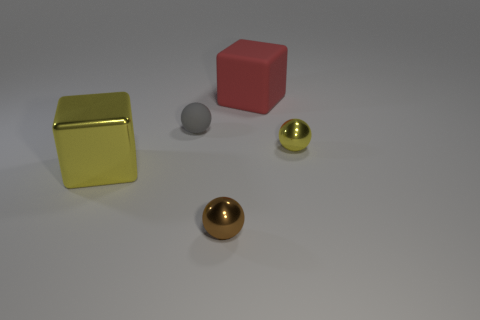There is a rubber ball that is the same size as the brown shiny thing; what color is it?
Provide a succinct answer. Gray. What is the material of the big cube left of the red object?
Your answer should be compact. Metal. Do the tiny shiny thing on the left side of the yellow metal sphere and the tiny object behind the tiny yellow metal thing have the same shape?
Provide a succinct answer. Yes. Are there the same number of metallic objects that are to the right of the big matte cube and small gray matte objects?
Keep it short and to the point. Yes. How many small gray balls have the same material as the red cube?
Your response must be concise. 1. What color is the small ball that is made of the same material as the large red thing?
Your answer should be compact. Gray. Does the metal cube have the same size as the cube behind the yellow metal block?
Keep it short and to the point. Yes. What shape is the big yellow metal object?
Your response must be concise. Cube. How many big blocks have the same color as the small rubber thing?
Keep it short and to the point. 0. The other matte thing that is the same shape as the big yellow object is what color?
Give a very brief answer. Red. 